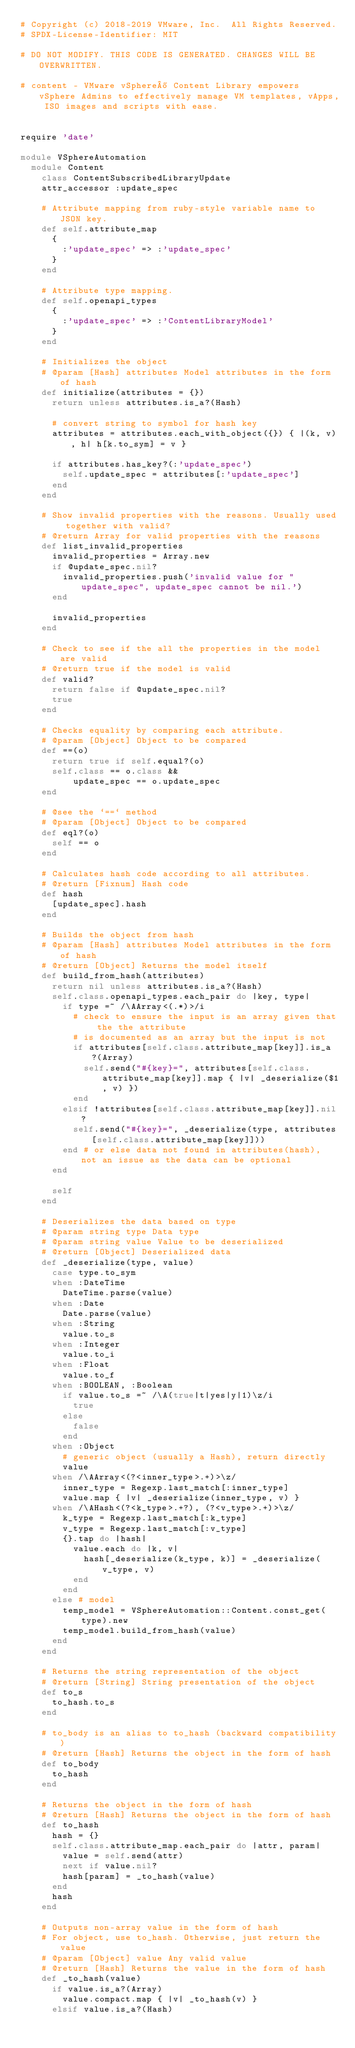<code> <loc_0><loc_0><loc_500><loc_500><_Ruby_># Copyright (c) 2018-2019 VMware, Inc.  All Rights Reserved.
# SPDX-License-Identifier: MIT

# DO NOT MODIFY. THIS CODE IS GENERATED. CHANGES WILL BE OVERWRITTEN.

# content - VMware vSphere® Content Library empowers vSphere Admins to effectively manage VM templates, vApps, ISO images and scripts with ease.


require 'date'

module VSphereAutomation
  module Content
    class ContentSubscribedLibraryUpdate
    attr_accessor :update_spec

    # Attribute mapping from ruby-style variable name to JSON key.
    def self.attribute_map
      {
        :'update_spec' => :'update_spec'
      }
    end

    # Attribute type mapping.
    def self.openapi_types
      {
        :'update_spec' => :'ContentLibraryModel'
      }
    end

    # Initializes the object
    # @param [Hash] attributes Model attributes in the form of hash
    def initialize(attributes = {})
      return unless attributes.is_a?(Hash)

      # convert string to symbol for hash key
      attributes = attributes.each_with_object({}) { |(k, v), h| h[k.to_sym] = v }

      if attributes.has_key?(:'update_spec')
        self.update_spec = attributes[:'update_spec']
      end
    end

    # Show invalid properties with the reasons. Usually used together with valid?
    # @return Array for valid properties with the reasons
    def list_invalid_properties
      invalid_properties = Array.new
      if @update_spec.nil?
        invalid_properties.push('invalid value for "update_spec", update_spec cannot be nil.')
      end

      invalid_properties
    end

    # Check to see if the all the properties in the model are valid
    # @return true if the model is valid
    def valid?
      return false if @update_spec.nil?
      true
    end

    # Checks equality by comparing each attribute.
    # @param [Object] Object to be compared
    def ==(o)
      return true if self.equal?(o)
      self.class == o.class &&
          update_spec == o.update_spec
    end

    # @see the `==` method
    # @param [Object] Object to be compared
    def eql?(o)
      self == o
    end

    # Calculates hash code according to all attributes.
    # @return [Fixnum] Hash code
    def hash
      [update_spec].hash
    end

    # Builds the object from hash
    # @param [Hash] attributes Model attributes in the form of hash
    # @return [Object] Returns the model itself
    def build_from_hash(attributes)
      return nil unless attributes.is_a?(Hash)
      self.class.openapi_types.each_pair do |key, type|
        if type =~ /\AArray<(.*)>/i
          # check to ensure the input is an array given that the the attribute
          # is documented as an array but the input is not
          if attributes[self.class.attribute_map[key]].is_a?(Array)
            self.send("#{key}=", attributes[self.class.attribute_map[key]].map { |v| _deserialize($1, v) })
          end
        elsif !attributes[self.class.attribute_map[key]].nil?
          self.send("#{key}=", _deserialize(type, attributes[self.class.attribute_map[key]]))
        end # or else data not found in attributes(hash), not an issue as the data can be optional
      end

      self
    end

    # Deserializes the data based on type
    # @param string type Data type
    # @param string value Value to be deserialized
    # @return [Object] Deserialized data
    def _deserialize(type, value)
      case type.to_sym
      when :DateTime
        DateTime.parse(value)
      when :Date
        Date.parse(value)
      when :String
        value.to_s
      when :Integer
        value.to_i
      when :Float
        value.to_f
      when :BOOLEAN, :Boolean
        if value.to_s =~ /\A(true|t|yes|y|1)\z/i
          true
        else
          false
        end
      when :Object
        # generic object (usually a Hash), return directly
        value
      when /\AArray<(?<inner_type>.+)>\z/
        inner_type = Regexp.last_match[:inner_type]
        value.map { |v| _deserialize(inner_type, v) }
      when /\AHash<(?<k_type>.+?), (?<v_type>.+)>\z/
        k_type = Regexp.last_match[:k_type]
        v_type = Regexp.last_match[:v_type]
        {}.tap do |hash|
          value.each do |k, v|
            hash[_deserialize(k_type, k)] = _deserialize(v_type, v)
          end
        end
      else # model
        temp_model = VSphereAutomation::Content.const_get(type).new
        temp_model.build_from_hash(value)
      end
    end

    # Returns the string representation of the object
    # @return [String] String presentation of the object
    def to_s
      to_hash.to_s
    end

    # to_body is an alias to to_hash (backward compatibility)
    # @return [Hash] Returns the object in the form of hash
    def to_body
      to_hash
    end

    # Returns the object in the form of hash
    # @return [Hash] Returns the object in the form of hash
    def to_hash
      hash = {}
      self.class.attribute_map.each_pair do |attr, param|
        value = self.send(attr)
        next if value.nil?
        hash[param] = _to_hash(value)
      end
      hash
    end

    # Outputs non-array value in the form of hash
    # For object, use to_hash. Otherwise, just return the value
    # @param [Object] value Any valid value
    # @return [Hash] Returns the value in the form of hash
    def _to_hash(value)
      if value.is_a?(Array)
        value.compact.map { |v| _to_hash(v) }
      elsif value.is_a?(Hash)</code> 